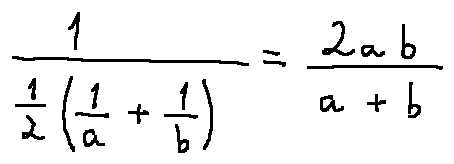Convert formula to latex. <formula><loc_0><loc_0><loc_500><loc_500>\frac { 1 } { \frac { 1 } { 2 } ( \frac { 1 } { a } + \frac { 1 } { b } ) } = \frac { 2 a b } { a + b }</formula> 